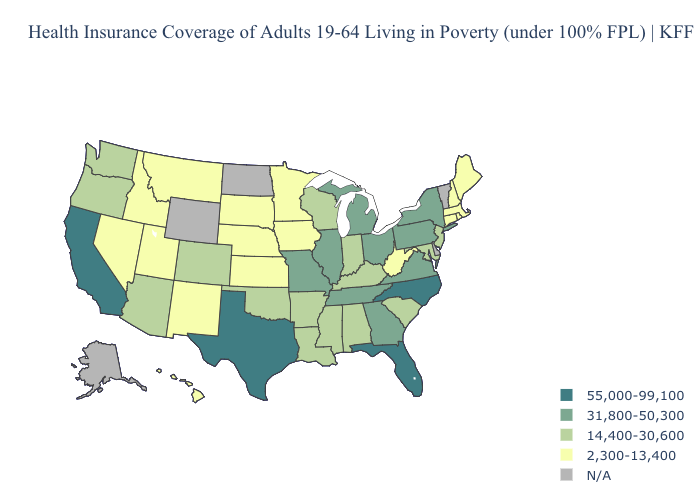What is the value of Indiana?
Short answer required. 14,400-30,600. Name the states that have a value in the range 2,300-13,400?
Quick response, please. Connecticut, Hawaii, Idaho, Iowa, Kansas, Maine, Massachusetts, Minnesota, Montana, Nebraska, Nevada, New Hampshire, New Mexico, Rhode Island, South Dakota, Utah, West Virginia. What is the highest value in the South ?
Quick response, please. 55,000-99,100. What is the lowest value in the USA?
Keep it brief. 2,300-13,400. What is the value of Rhode Island?
Quick response, please. 2,300-13,400. Name the states that have a value in the range N/A?
Quick response, please. Alaska, Delaware, North Dakota, Vermont, Wyoming. Is the legend a continuous bar?
Short answer required. No. Does Michigan have the lowest value in the MidWest?
Answer briefly. No. Name the states that have a value in the range 14,400-30,600?
Be succinct. Alabama, Arizona, Arkansas, Colorado, Indiana, Kentucky, Louisiana, Maryland, Mississippi, New Jersey, Oklahoma, Oregon, South Carolina, Washington, Wisconsin. Among the states that border Iowa , which have the highest value?
Keep it brief. Illinois, Missouri. What is the value of Arkansas?
Be succinct. 14,400-30,600. How many symbols are there in the legend?
Be succinct. 5. Does Alabama have the lowest value in the USA?
Short answer required. No. What is the lowest value in the South?
Give a very brief answer. 2,300-13,400. 